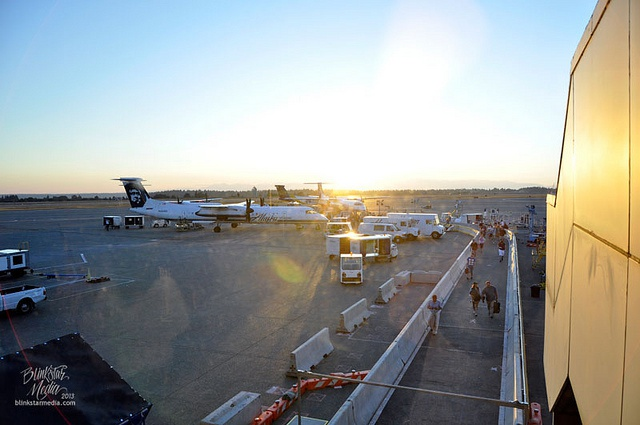Describe the objects in this image and their specific colors. I can see airplane in darkgray, black, and gray tones, truck in darkgray, olive, gray, and white tones, truck in darkgray, black, gray, and blue tones, truck in darkgray, gray, and lightgray tones, and airplane in darkgray, lightgray, olive, and tan tones in this image. 